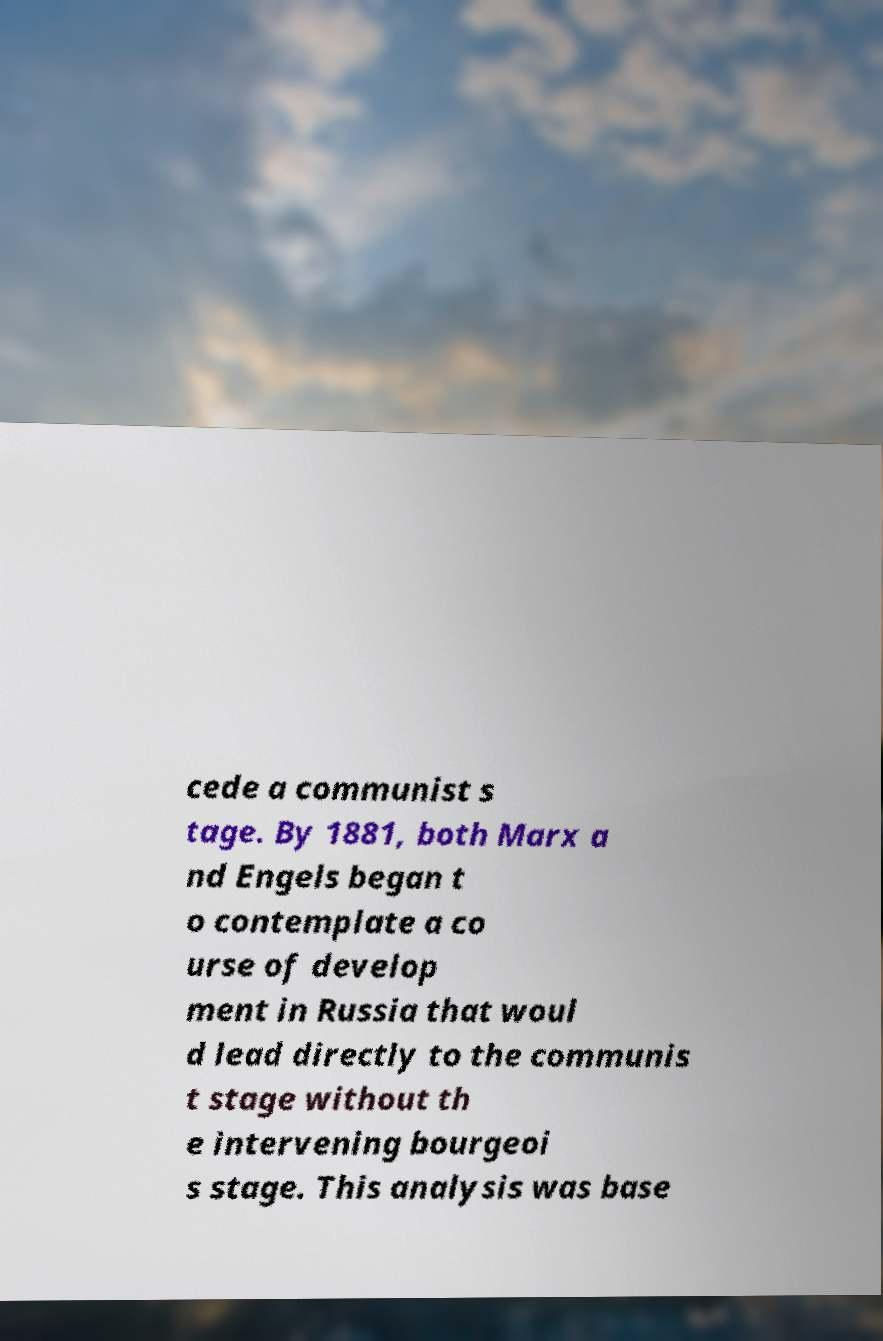Can you read and provide the text displayed in the image?This photo seems to have some interesting text. Can you extract and type it out for me? cede a communist s tage. By 1881, both Marx a nd Engels began t o contemplate a co urse of develop ment in Russia that woul d lead directly to the communis t stage without th e intervening bourgeoi s stage. This analysis was base 